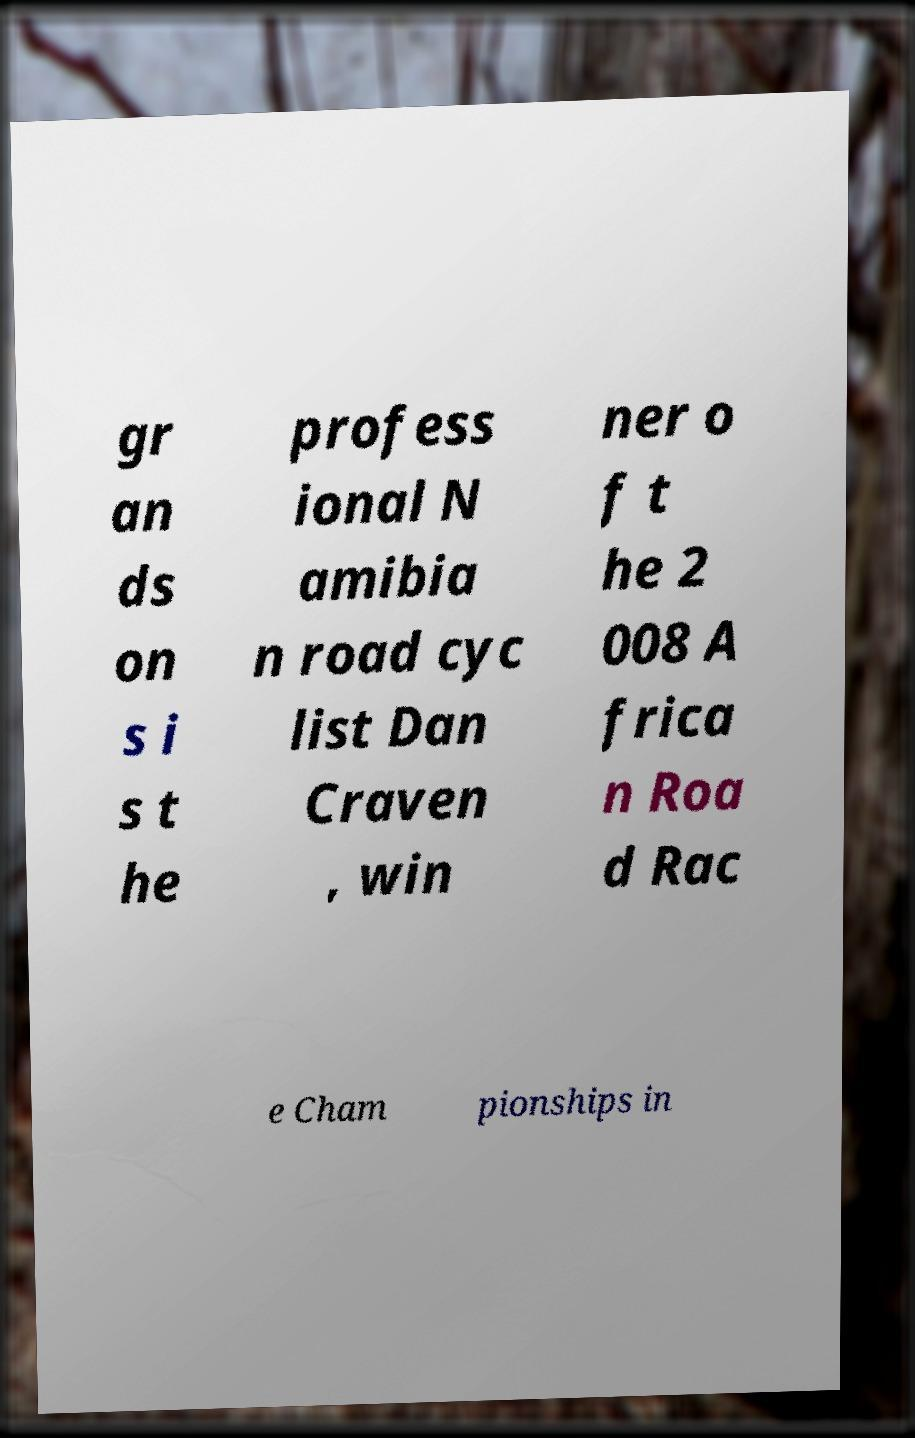For documentation purposes, I need the text within this image transcribed. Could you provide that? gr an ds on s i s t he profess ional N amibia n road cyc list Dan Craven , win ner o f t he 2 008 A frica n Roa d Rac e Cham pionships in 